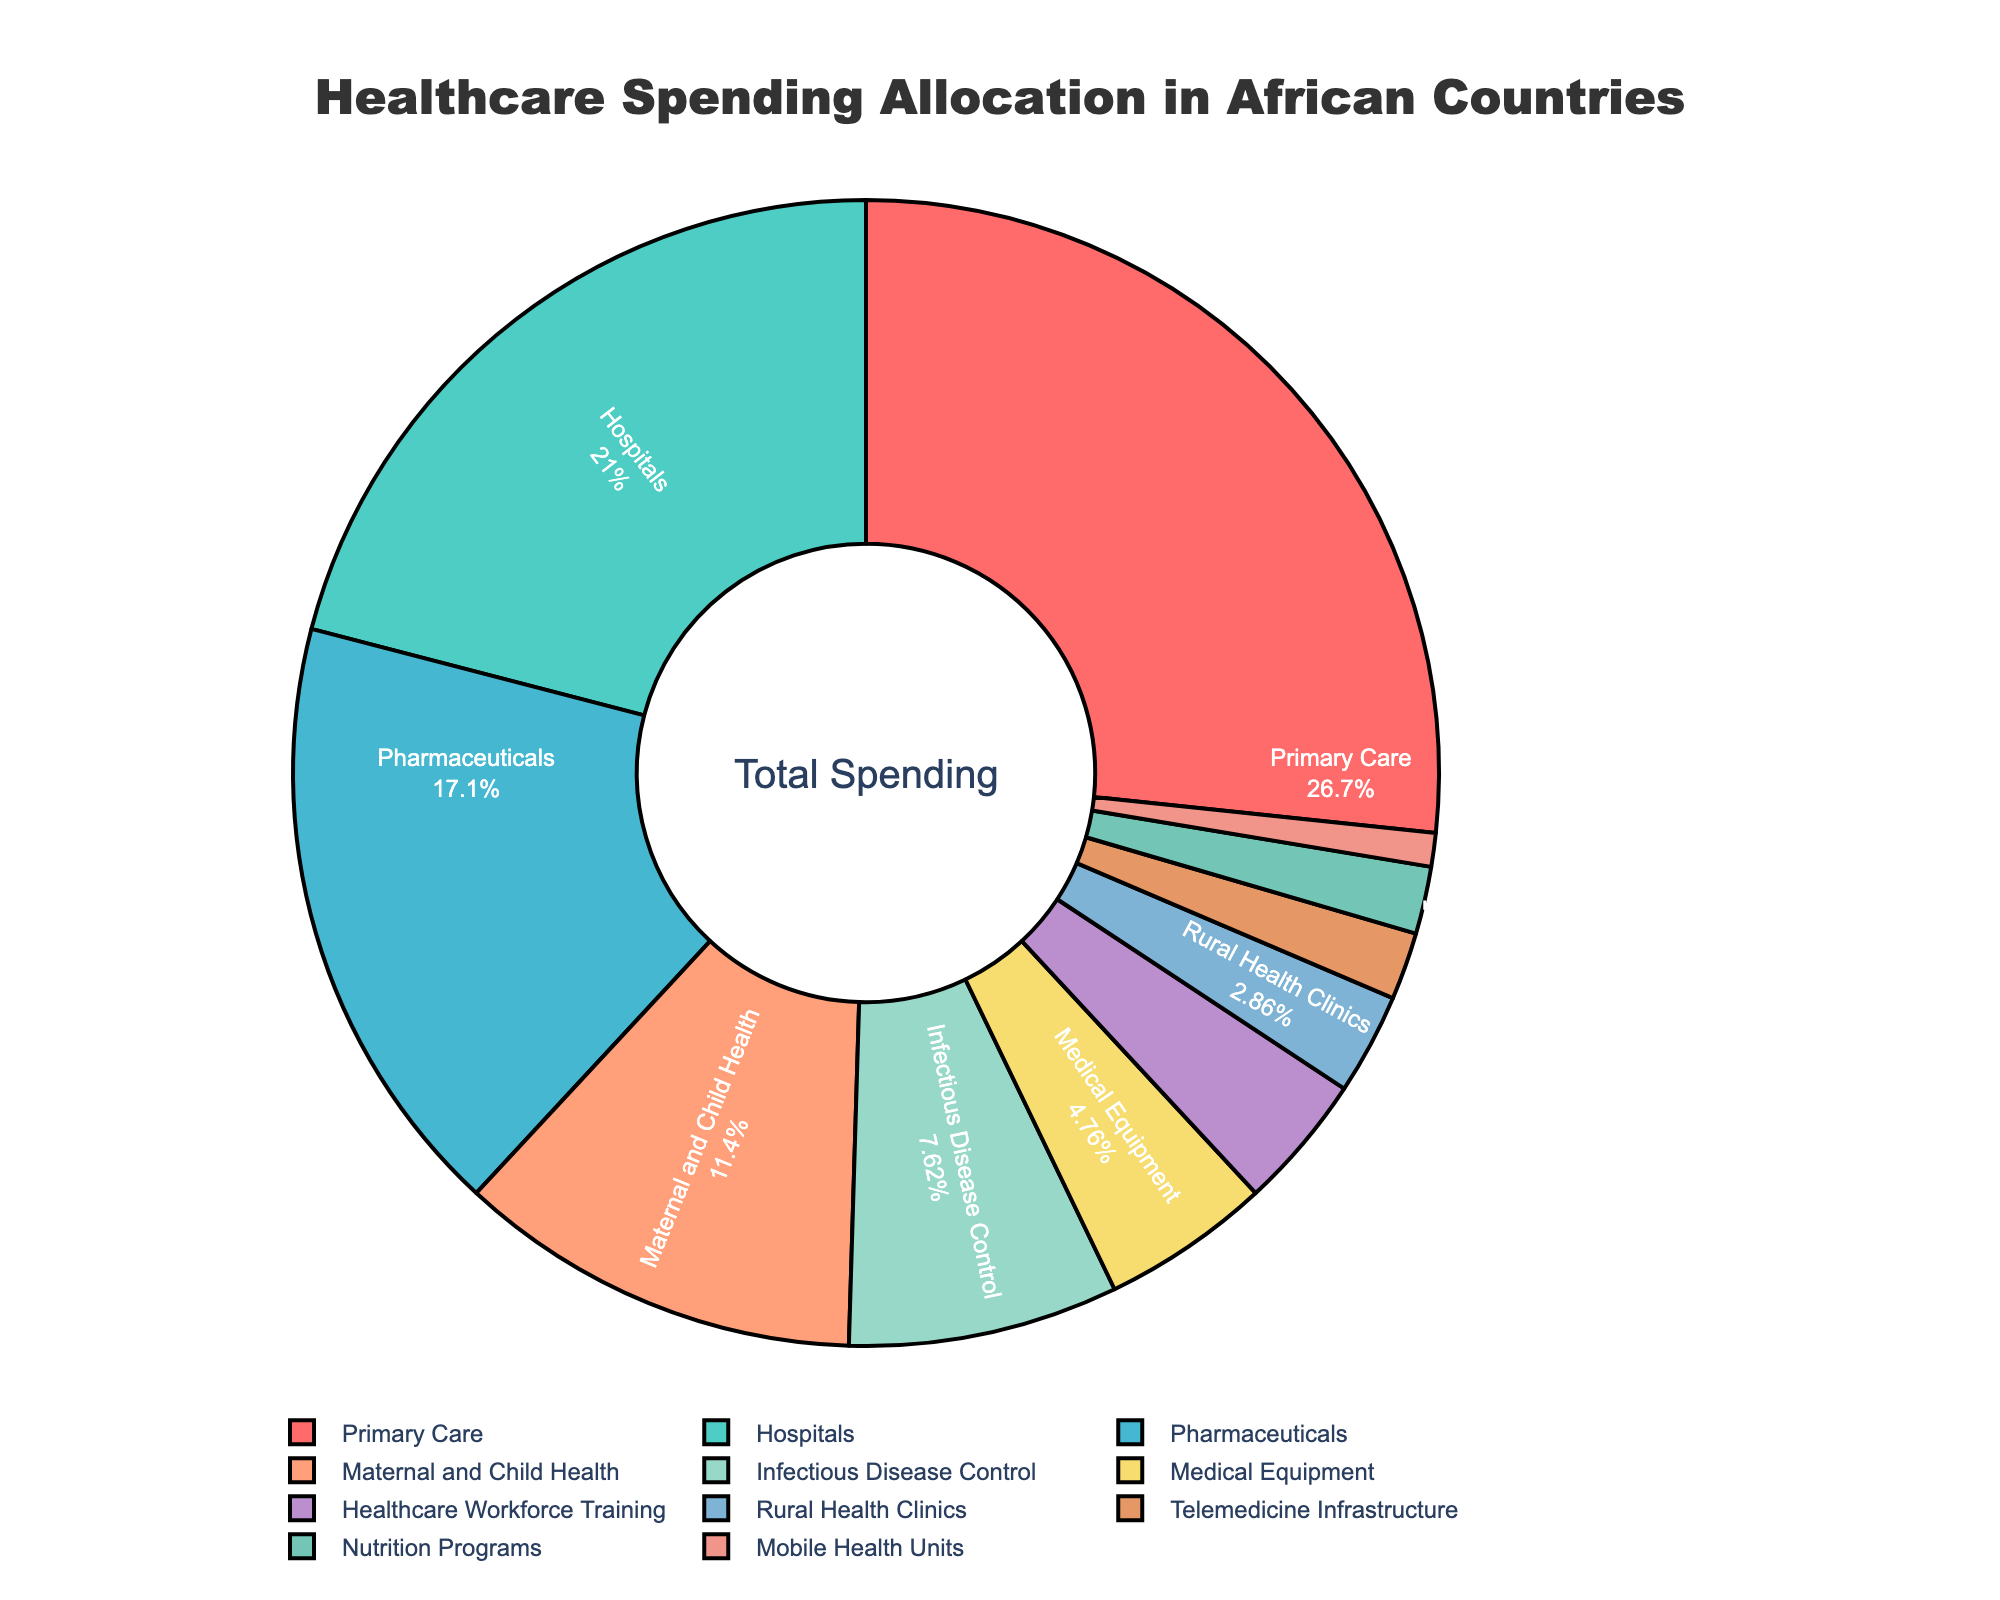What percentage of healthcare spending is allocated to Hospitals and Pharmaceuticals combined? First, find the percentage for Hospitals (22%) and Pharmaceuticals (18%). Then, add them together: 22% + 18% = 40%.
Answer: 40% Which sector has the smallest share of healthcare spending? Identify the sector with the lowest percentage value. Mobile Health Units have the smallest share at 1%.
Answer: Mobile Health Units How much more is spent on Primary Care compared to Infectious Disease Control? Subtract the percentage of Infectious Disease Control (8%) from Primary Care (28%): 28% - 8% = 20%.
Answer: 20% Is the percentage of healthcare spending on Maternal and Child Health greater than the combined spending on Rural Health Clinics and Telemedicine Infrastructure? Compare Maternal and Child Health (12%) to the sum of Rural Health Clinics (3%) and Telemedicine Infrastructure (2%): 12% vs. 3% + 2% = 5%. Yes, 12% is greater than 5%.
Answer: Yes Which sector has a darker shade of green, and what is its healthcare spending percentage? Locate the sector with a darker shade of green. Pharmaceuticals are indicated by a darker shade of green and have a spending percentage of 18%.
Answer: Pharmaceuticals, 18% Rank the top three sectors in terms of healthcare spending allocation. List the sectors and their percentages in descending order: Primary Care (28%), Hospitals (22%), Pharmaceuticals (18%).
Answer: Primary Care, Hospitals, Pharmaceuticals What percentage of healthcare spending goes to sectors other than the top three? Add the percentages of the top three sectors: 28% + 22% + 18% = 68%. Subtract this from 100%: 100% - 68% = 32%.
Answer: 32% If spending on Medical Equipment and Nutrition Programs is increased by 1%, what will be their new percentages? Add 1% to Medical Equipment (5%) and Nutrition Programs (2%): Medical Equipment will be 5% + 1% = 6%, and Nutrition Programs will be 2% + 1% = 3%.
Answer: Medical Equipment: 6%, Nutrition Programs: 3% 